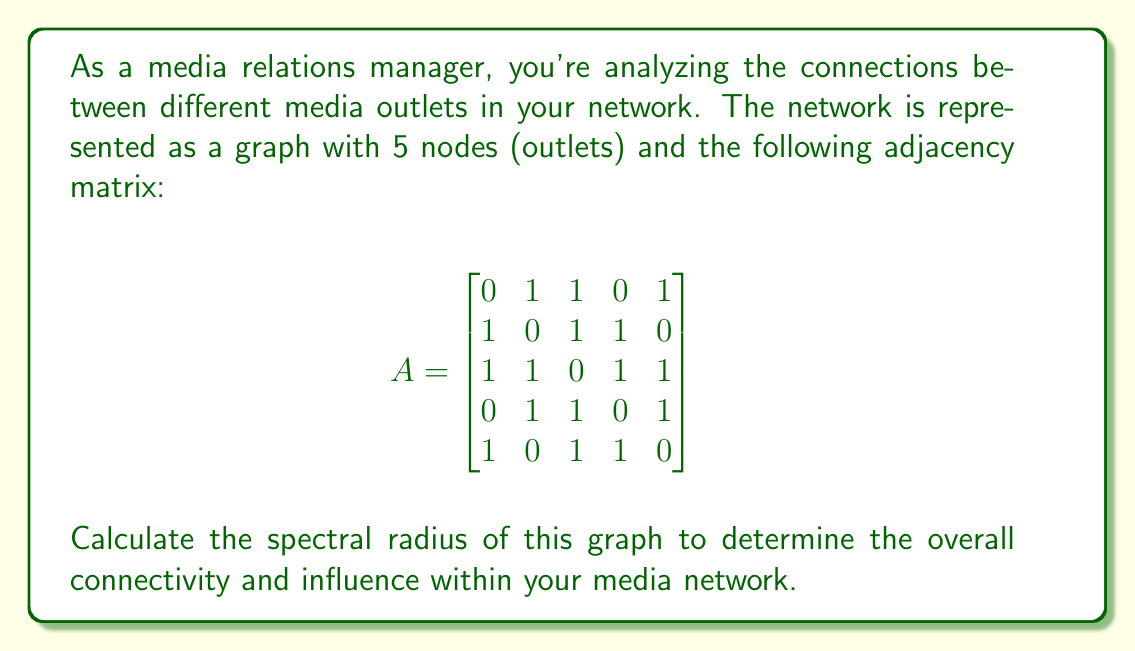Give your solution to this math problem. To find the spectral radius of the graph, we need to follow these steps:

1) The spectral radius is the largest absolute eigenvalue of the adjacency matrix A.

2) To find the eigenvalues, we need to solve the characteristic equation:
   $\det(A - \lambda I) = 0$

3) Expanding this determinant:
   $$\begin{vmatrix}
   -\lambda & 1 & 1 & 0 & 1 \\
   1 & -\lambda & 1 & 1 & 0 \\
   1 & 1 & -\lambda & 1 & 1 \\
   0 & 1 & 1 & -\lambda & 1 \\
   1 & 0 & 1 & 1 & -\lambda
   \end{vmatrix} = 0$$

4) This yields the characteristic polynomial:
   $\lambda^5 - 8\lambda^3 - 8\lambda^2 + 12\lambda + 4 = 0$

5) This polynomial is difficult to solve analytically, so we use numerical methods to approximate the roots.

6) Using a computer algebra system or numerical solver, we find the roots (eigenvalues) to be approximately:
   $\lambda_1 \approx 2.7321$
   $\lambda_2 \approx -1.7321$
   $\lambda_3 \approx 1.0000$
   $\lambda_4 \approx -1.0000$
   $\lambda_5 \approx 0.0000$

7) The spectral radius is the largest absolute value among these eigenvalues.

Therefore, the spectral radius is approximately 2.7321.

This value indicates a moderately high level of connectivity in your media network, suggesting significant potential for information flow and influence between the outlets.
Answer: $2.7321$ 